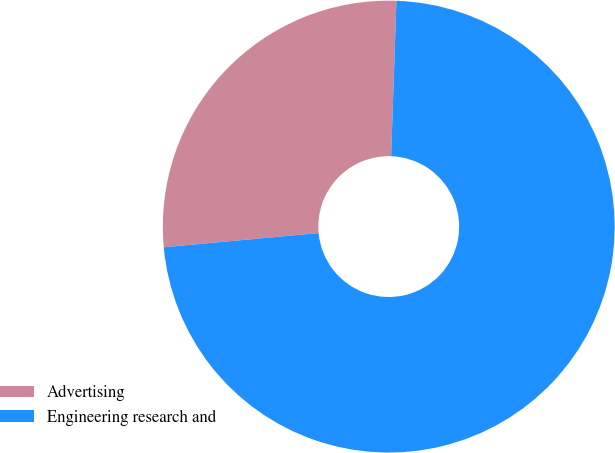Convert chart to OTSL. <chart><loc_0><loc_0><loc_500><loc_500><pie_chart><fcel>Advertising<fcel>Engineering research and<nl><fcel>27.0%<fcel>73.0%<nl></chart> 